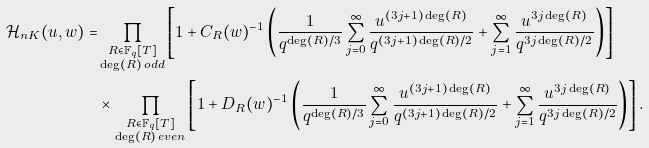<formula> <loc_0><loc_0><loc_500><loc_500>\mathcal { H } _ { n K } ( u , w ) = & \prod _ { \substack { R \in \mathbb { F } _ { q } [ T ] \\ \deg ( R ) \, o d d } } \left [ 1 + C _ { R } ( w ) ^ { - 1 } \left ( \frac { 1 } { q ^ { \deg ( R ) / 3 } } \sum _ { j = 0 } ^ { \infty } \frac { u ^ { ( 3 j + 1 ) \deg ( R ) } } { q ^ { ( 3 j + 1 ) \deg ( R ) / 2 } } + \sum _ { j = 1 } ^ { \infty } \frac { u ^ { 3 j \deg ( R ) } } { q ^ { 3 j \deg ( R ) / 2 } } \right ) \right ] \\ & \times \prod _ { \substack { R \in \mathbb { F } _ { q } [ T ] \\ \deg ( R ) \, e v e n } } \left [ 1 + D _ { R } ( w ) ^ { - 1 } \left ( \frac { 1 } { q ^ { \deg ( R ) / 3 } } \sum _ { j = 0 } ^ { \infty } \frac { u ^ { ( 3 j + 1 ) \deg ( R ) } } { q ^ { ( 3 j + 1 ) \deg ( R ) / 2 } } + \sum _ { j = 1 } ^ { \infty } \frac { u ^ { 3 j \deg ( R ) } } { q ^ { 3 j \deg ( R ) / 2 } } \right ) \right ] .</formula> 